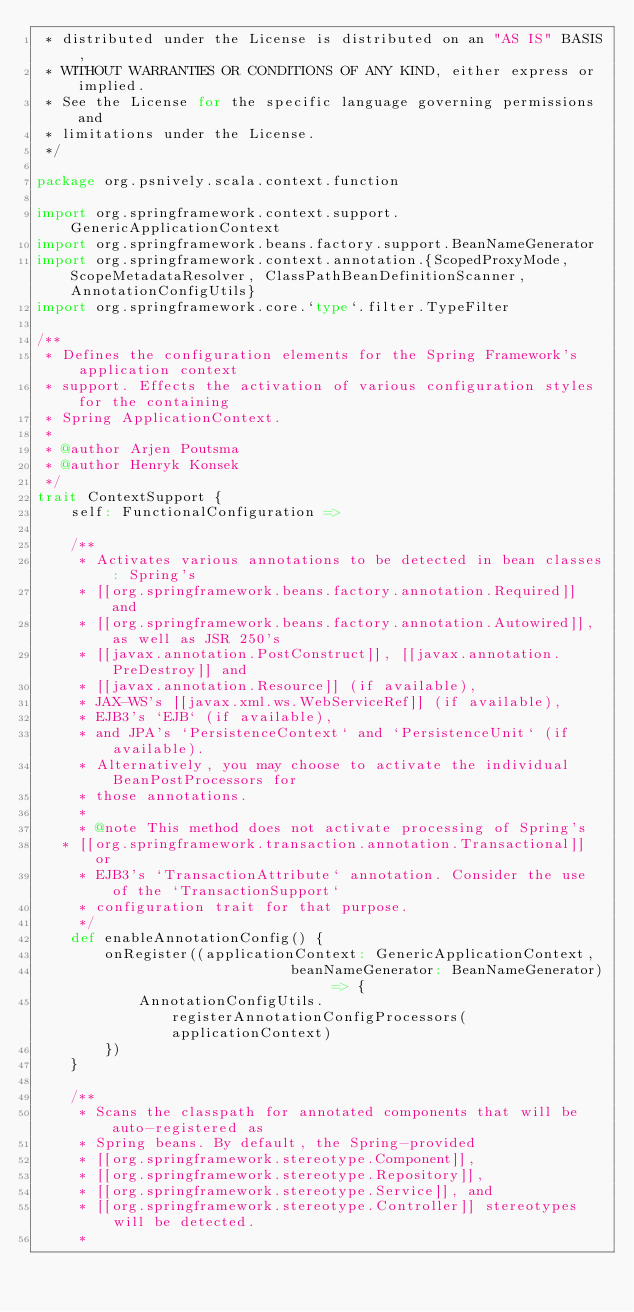Convert code to text. <code><loc_0><loc_0><loc_500><loc_500><_Scala_> * distributed under the License is distributed on an "AS IS" BASIS,
 * WITHOUT WARRANTIES OR CONDITIONS OF ANY KIND, either express or implied.
 * See the License for the specific language governing permissions and
 * limitations under the License.
 */

package org.psnively.scala.context.function

import org.springframework.context.support.GenericApplicationContext
import org.springframework.beans.factory.support.BeanNameGenerator
import org.springframework.context.annotation.{ScopedProxyMode, ScopeMetadataResolver, ClassPathBeanDefinitionScanner, AnnotationConfigUtils}
import org.springframework.core.`type`.filter.TypeFilter

/**
 * Defines the configuration elements for the Spring Framework's application context
 * support. Effects the activation of various configuration styles for the containing
 * Spring ApplicationContext.
 *
 * @author Arjen Poutsma
 * @author Henryk Konsek
 */
trait ContextSupport {
	self: FunctionalConfiguration =>

	/**
	 * Activates various annotations to be detected in bean classes: Spring's
	 * [[org.springframework.beans.factory.annotation.Required]] and
	 * [[org.springframework.beans.factory.annotation.Autowired]], as well as JSR 250's
	 * [[javax.annotation.PostConstruct]], [[javax.annotation.PreDestroy]] and
	 * [[javax.annotation.Resource]] (if available),
	 * JAX-WS's [[javax.xml.ws.WebServiceRef]] (if available),
	 * EJB3's `EJB` (if available),
	 * and JPA's `PersistenceContext` and `PersistenceUnit` (if available).
	 * Alternatively, you may choose to activate the individual BeanPostProcessors for
	 * those annotations.
	 *
	 * @note This method does not activate processing of Spring's
   * [[org.springframework.transaction.annotation.Transactional]] or
	 * EJB3's `TransactionAttribute` annotation. Consider the use of the `TransactionSupport`
	 * configuration trait for that purpose.
	 */
	def enableAnnotationConfig() {
		onRegister((applicationContext: GenericApplicationContext,
		                      beanNameGenerator: BeanNameGenerator) => {
			AnnotationConfigUtils.registerAnnotationConfigProcessors(applicationContext)
		})
	}

	/**
	 * Scans the classpath for annotated components that will be auto-registered as
	 * Spring beans. By default, the Spring-provided
	 * [[org.springframework.stereotype.Component]],
	 * [[org.springframework.stereotype.Repository]],
	 * [[org.springframework.stereotype.Service]], and
	 * [[org.springframework.stereotype.Controller]] stereotypes will be detected.
	 *</code> 